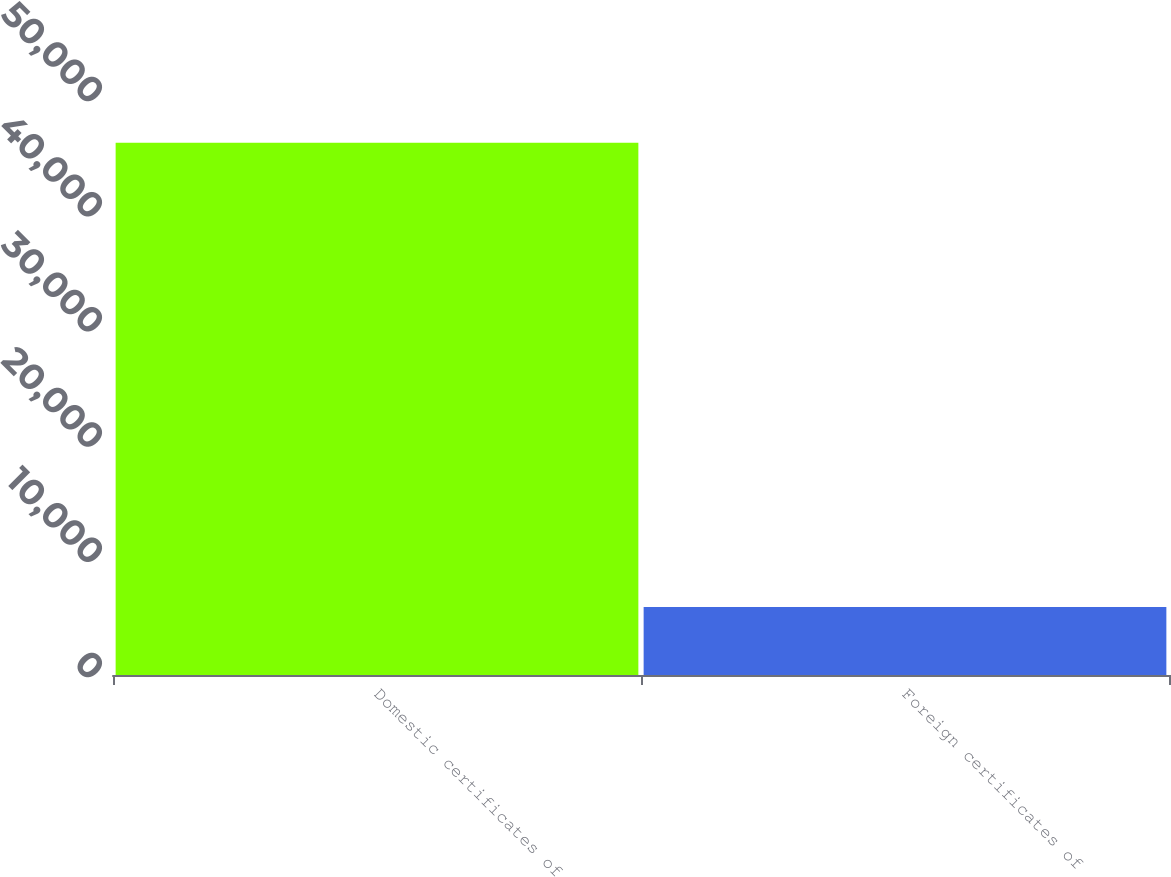Convert chart to OTSL. <chart><loc_0><loc_0><loc_500><loc_500><bar_chart><fcel>Domestic certificates of<fcel>Foreign certificates of<nl><fcel>46199<fcel>5900<nl></chart> 